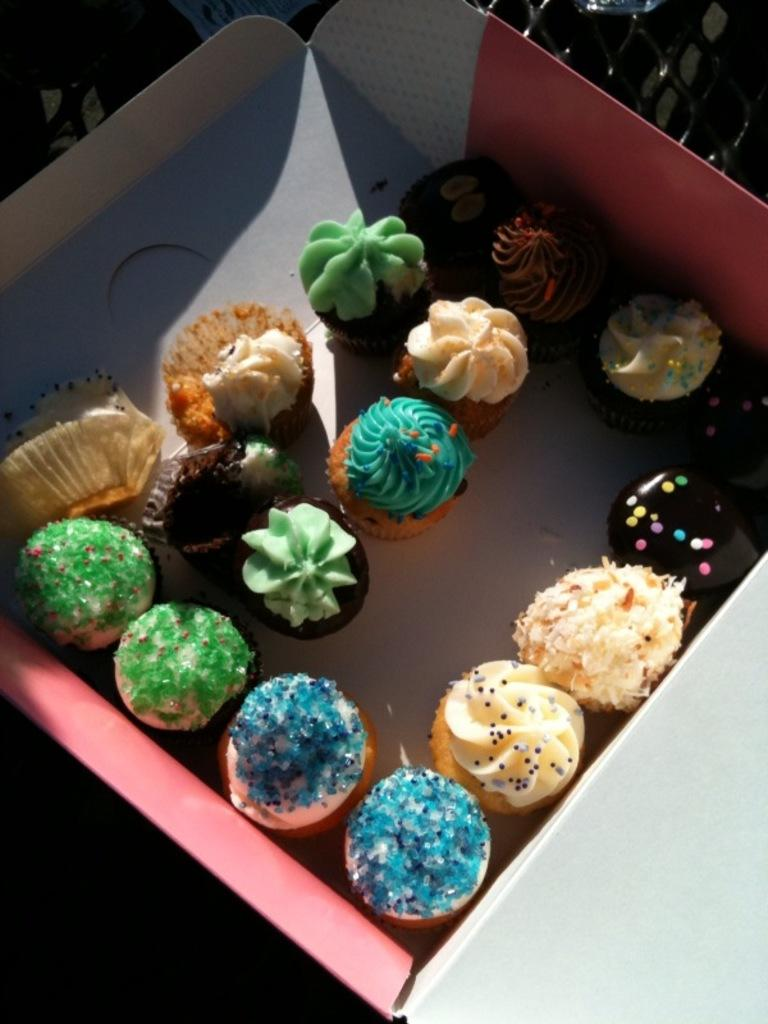What object is present in the image? There is a box in the image. What is inside the box? There are cupcakes inside the box. What type of brush is used to paint the war scene depicted on the cupcakes? There is no war scene or brush present on the cupcakes; they are simply cupcakes inside a box. 